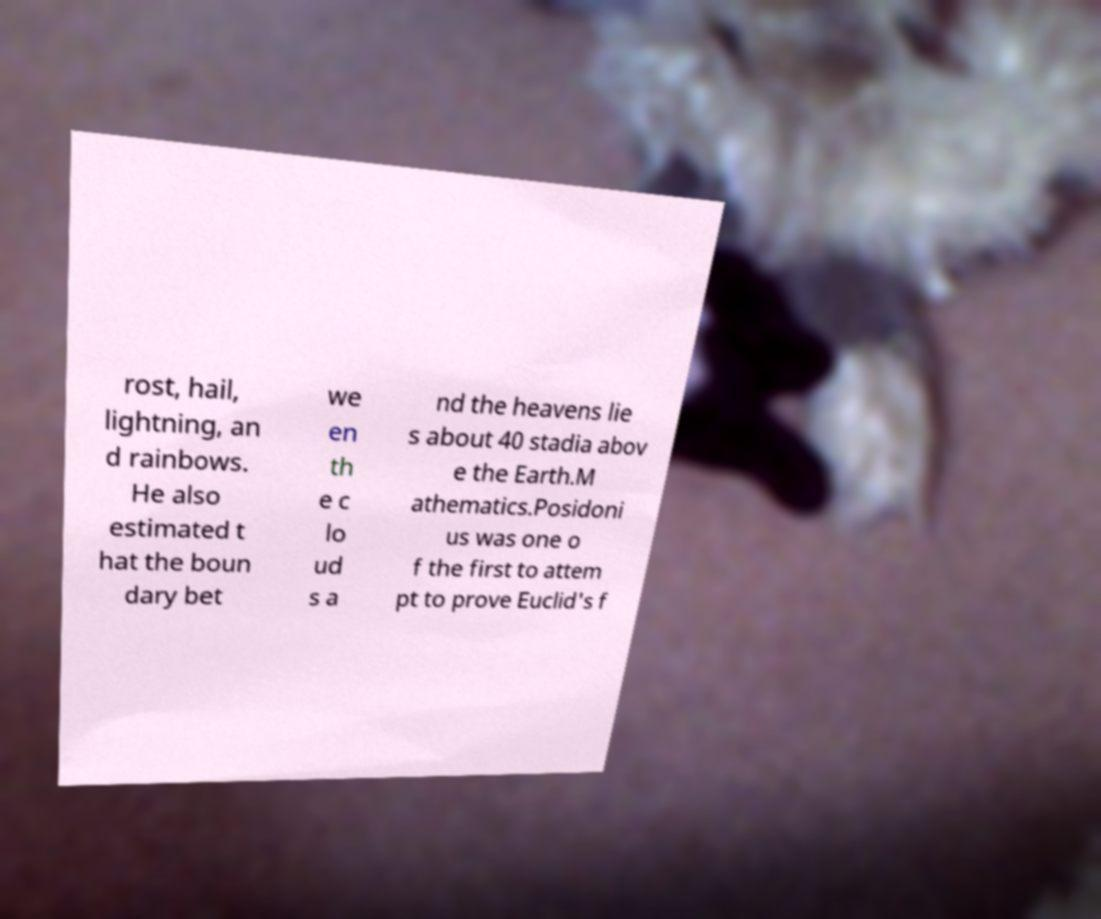For documentation purposes, I need the text within this image transcribed. Could you provide that? rost, hail, lightning, an d rainbows. He also estimated t hat the boun dary bet we en th e c lo ud s a nd the heavens lie s about 40 stadia abov e the Earth.M athematics.Posidoni us was one o f the first to attem pt to prove Euclid's f 